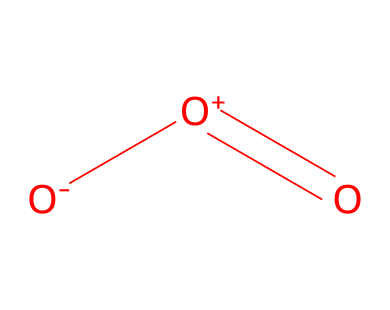What is the molecular formula of ozone? The SMILES representation indicates three oxygen atoms are present in the structure, which corresponds to the molecular formula O3.
Answer: O3 How many bonds are present in the ozone molecule? In the SMILES representation, there appears to be a double bond (indicated by the "=") and a single bond between the other oxygen atoms, resulting in a total of 2 bonds.
Answer: 2 What type of molecule is represented by this structure? The chemical structure represents ozone, which is a common example of a gaseous molecule in the Earth's atmosphere, particularly within the stratosphere.
Answer: ozone What is the charge of the central atom in ozone? The central atom in the structure is represented with a positive charge, denoted as [O+], indicating that it has lost an electron.
Answer: positive What type of bonding is primarily involved in ozone's structure? The structure shows both single and double bonds, demonstrating the presence of covalent bonding between the oxygen atoms, which is characteristic of molecular gases like ozone.
Answer: covalent Why is the ozone molecule considered a gas at atmospheric conditions? Ozone has lower intermolecular forces due to its molecular structure and gaseous state at atmospheric temperatures, allowing it to disperse easily in the atmosphere.
Answer: low intermolecular forces How does ozone absorb ultraviolet light? Ozone's structure includes specific electronic configurations that allow it to absorb UV light, thereby preventing these harmful rays from reaching the Earth's surface.
Answer: specific electronic configurations 